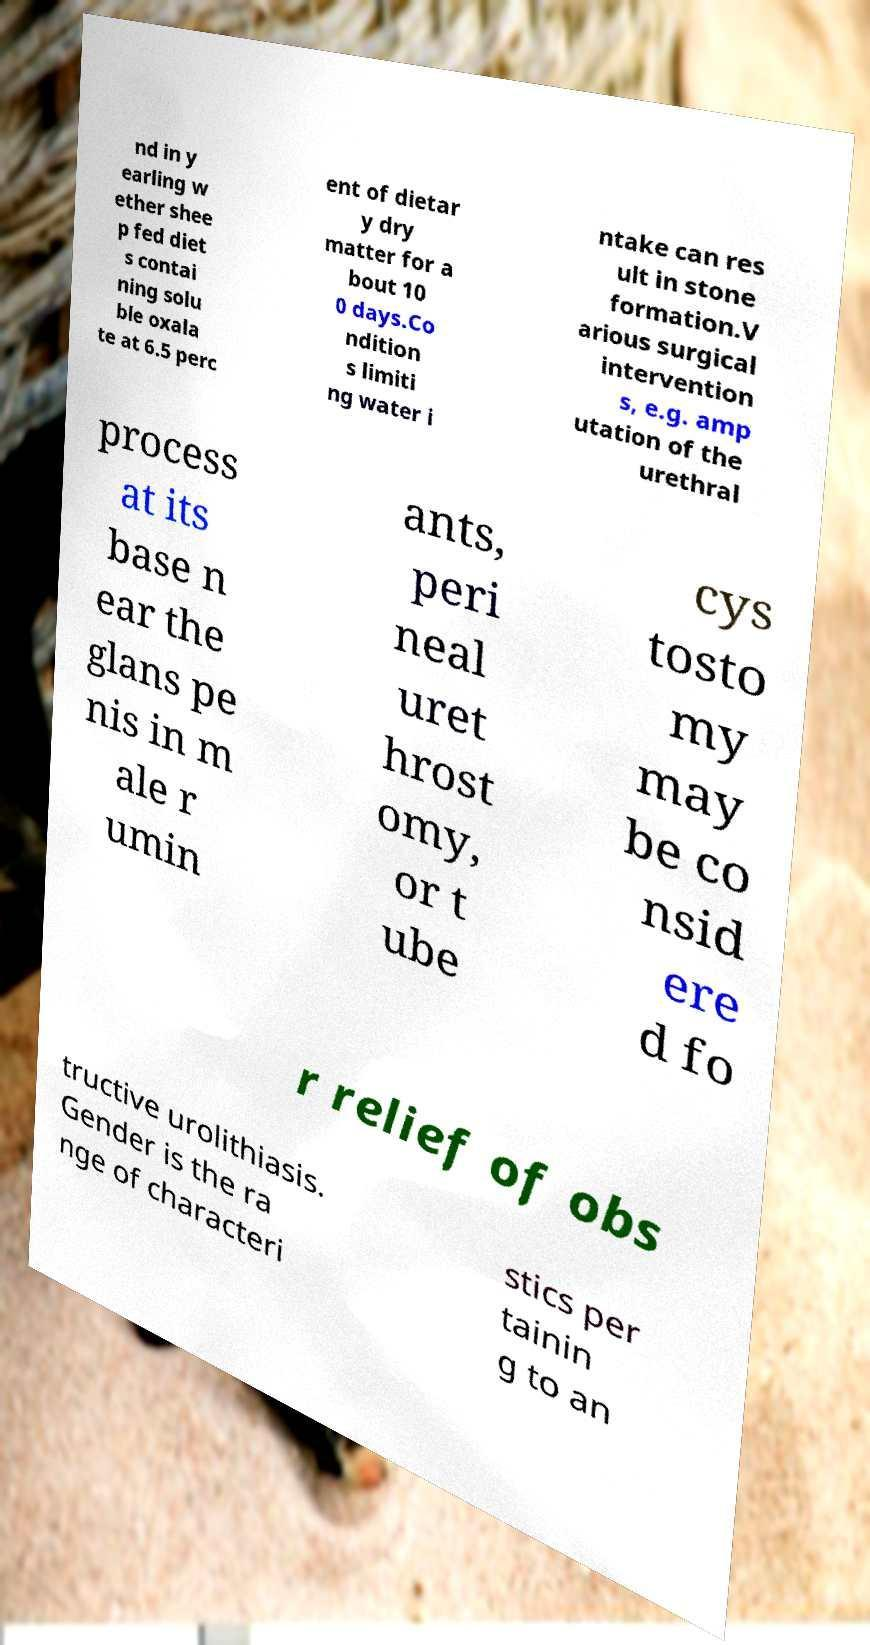Can you accurately transcribe the text from the provided image for me? nd in y earling w ether shee p fed diet s contai ning solu ble oxala te at 6.5 perc ent of dietar y dry matter for a bout 10 0 days.Co ndition s limiti ng water i ntake can res ult in stone formation.V arious surgical intervention s, e.g. amp utation of the urethral process at its base n ear the glans pe nis in m ale r umin ants, peri neal uret hrost omy, or t ube cys tosto my may be co nsid ere d fo r relief of obs tructive urolithiasis. Gender is the ra nge of characteri stics per tainin g to an 